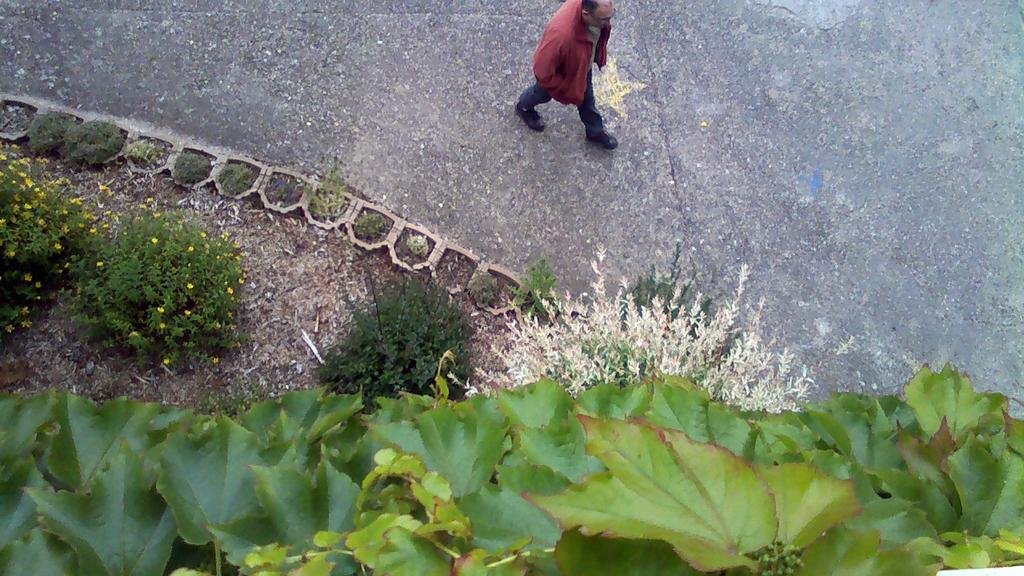What is the man in the image doing? The man is walking in the image. What can be seen in the background or foreground of the image? There are plants in the image. Are there any specific features of the plants? Yes, there are flowers associated with the plants in the image. How many kittens are playing with the hose near the plants in the image? There are no kittens or hose present in the image; it only features a man walking and plants with flowers. 